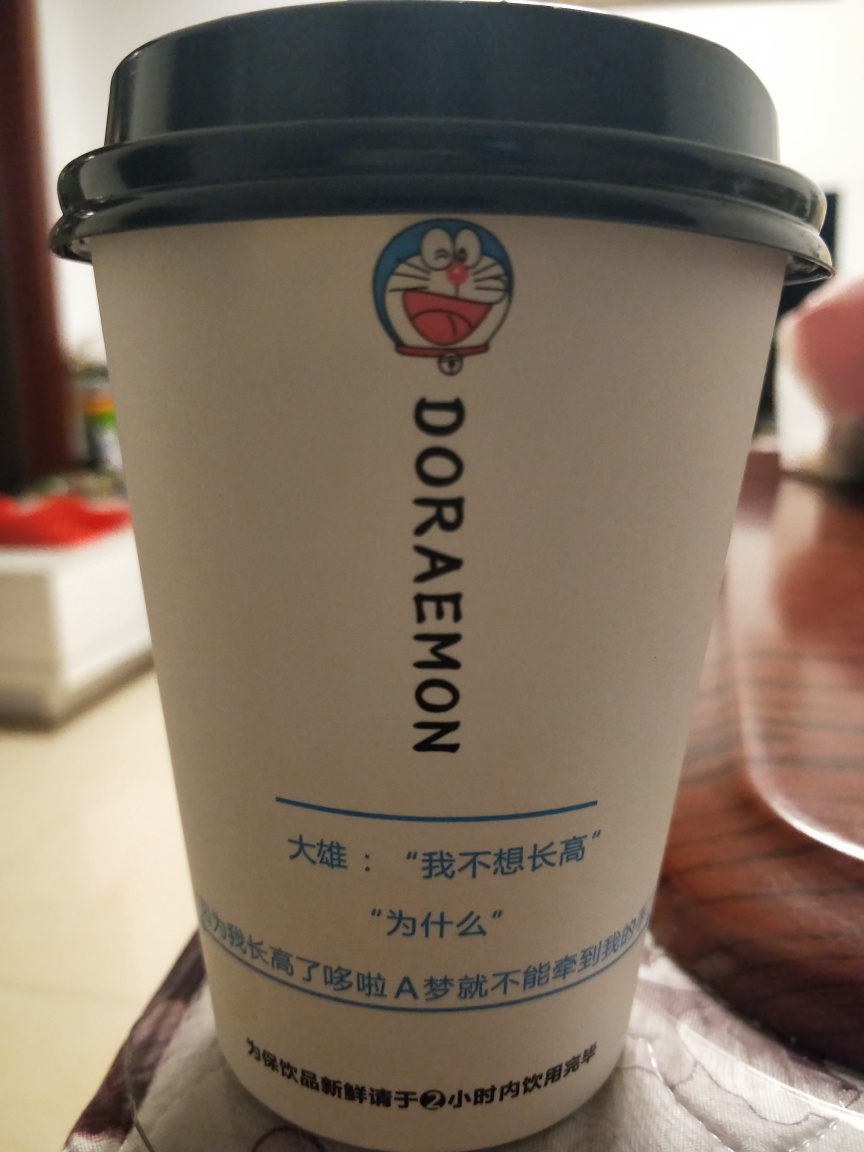How well are the texture details on the cup preserved in this image? The texture details on the cup are decently preserved in the image, with clear visibility of the character's illustration, text describing the character, as well as the smaller Chinese characters underneath. Although there is some loss of finer texture details due to image compression or focus, the vital elements are competently captured, providing a satisfactory representation. 